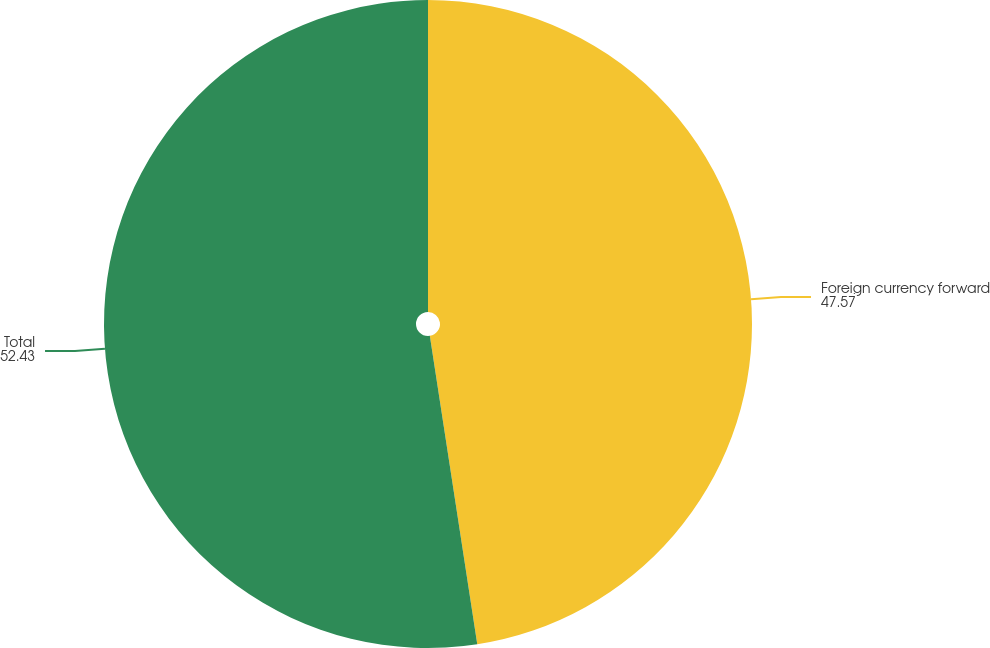Convert chart to OTSL. <chart><loc_0><loc_0><loc_500><loc_500><pie_chart><fcel>Foreign currency forward<fcel>Total<nl><fcel>47.57%<fcel>52.43%<nl></chart> 